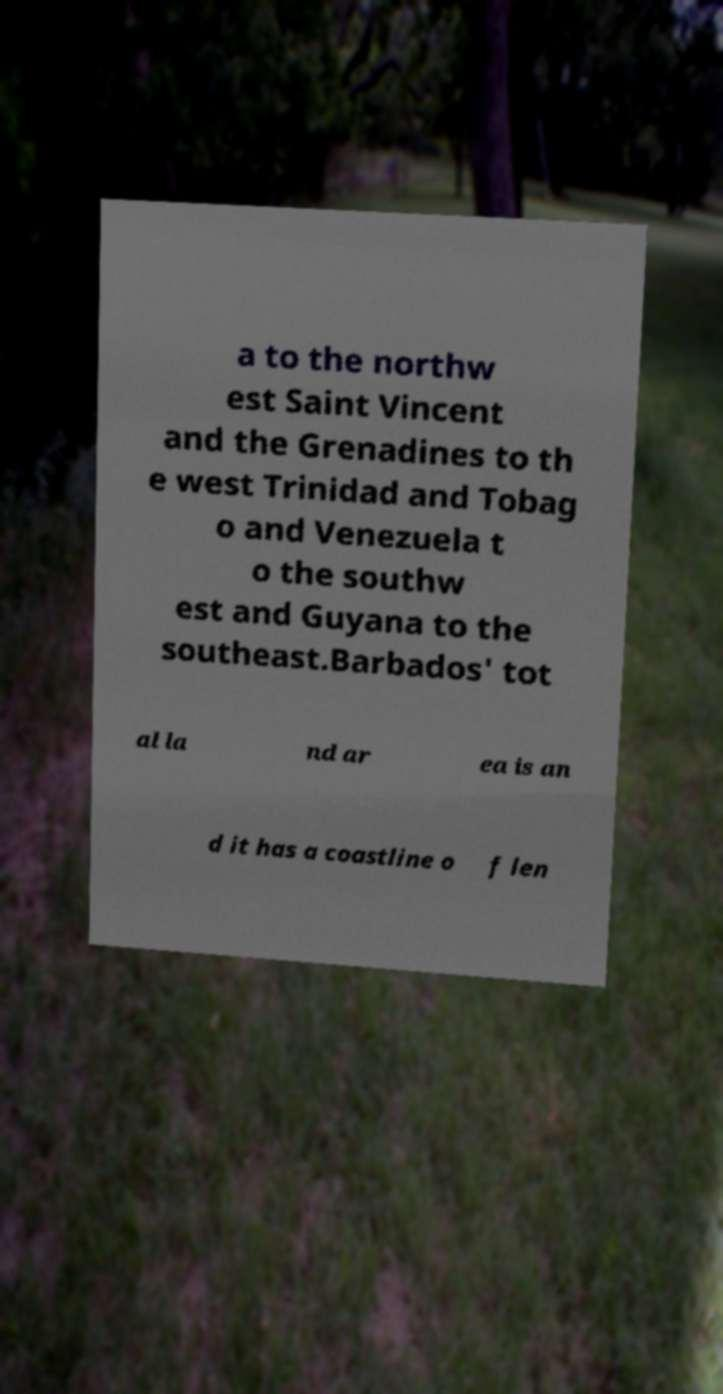Please read and relay the text visible in this image. What does it say? a to the northw est Saint Vincent and the Grenadines to th e west Trinidad and Tobag o and Venezuela t o the southw est and Guyana to the southeast.Barbados' tot al la nd ar ea is an d it has a coastline o f len 